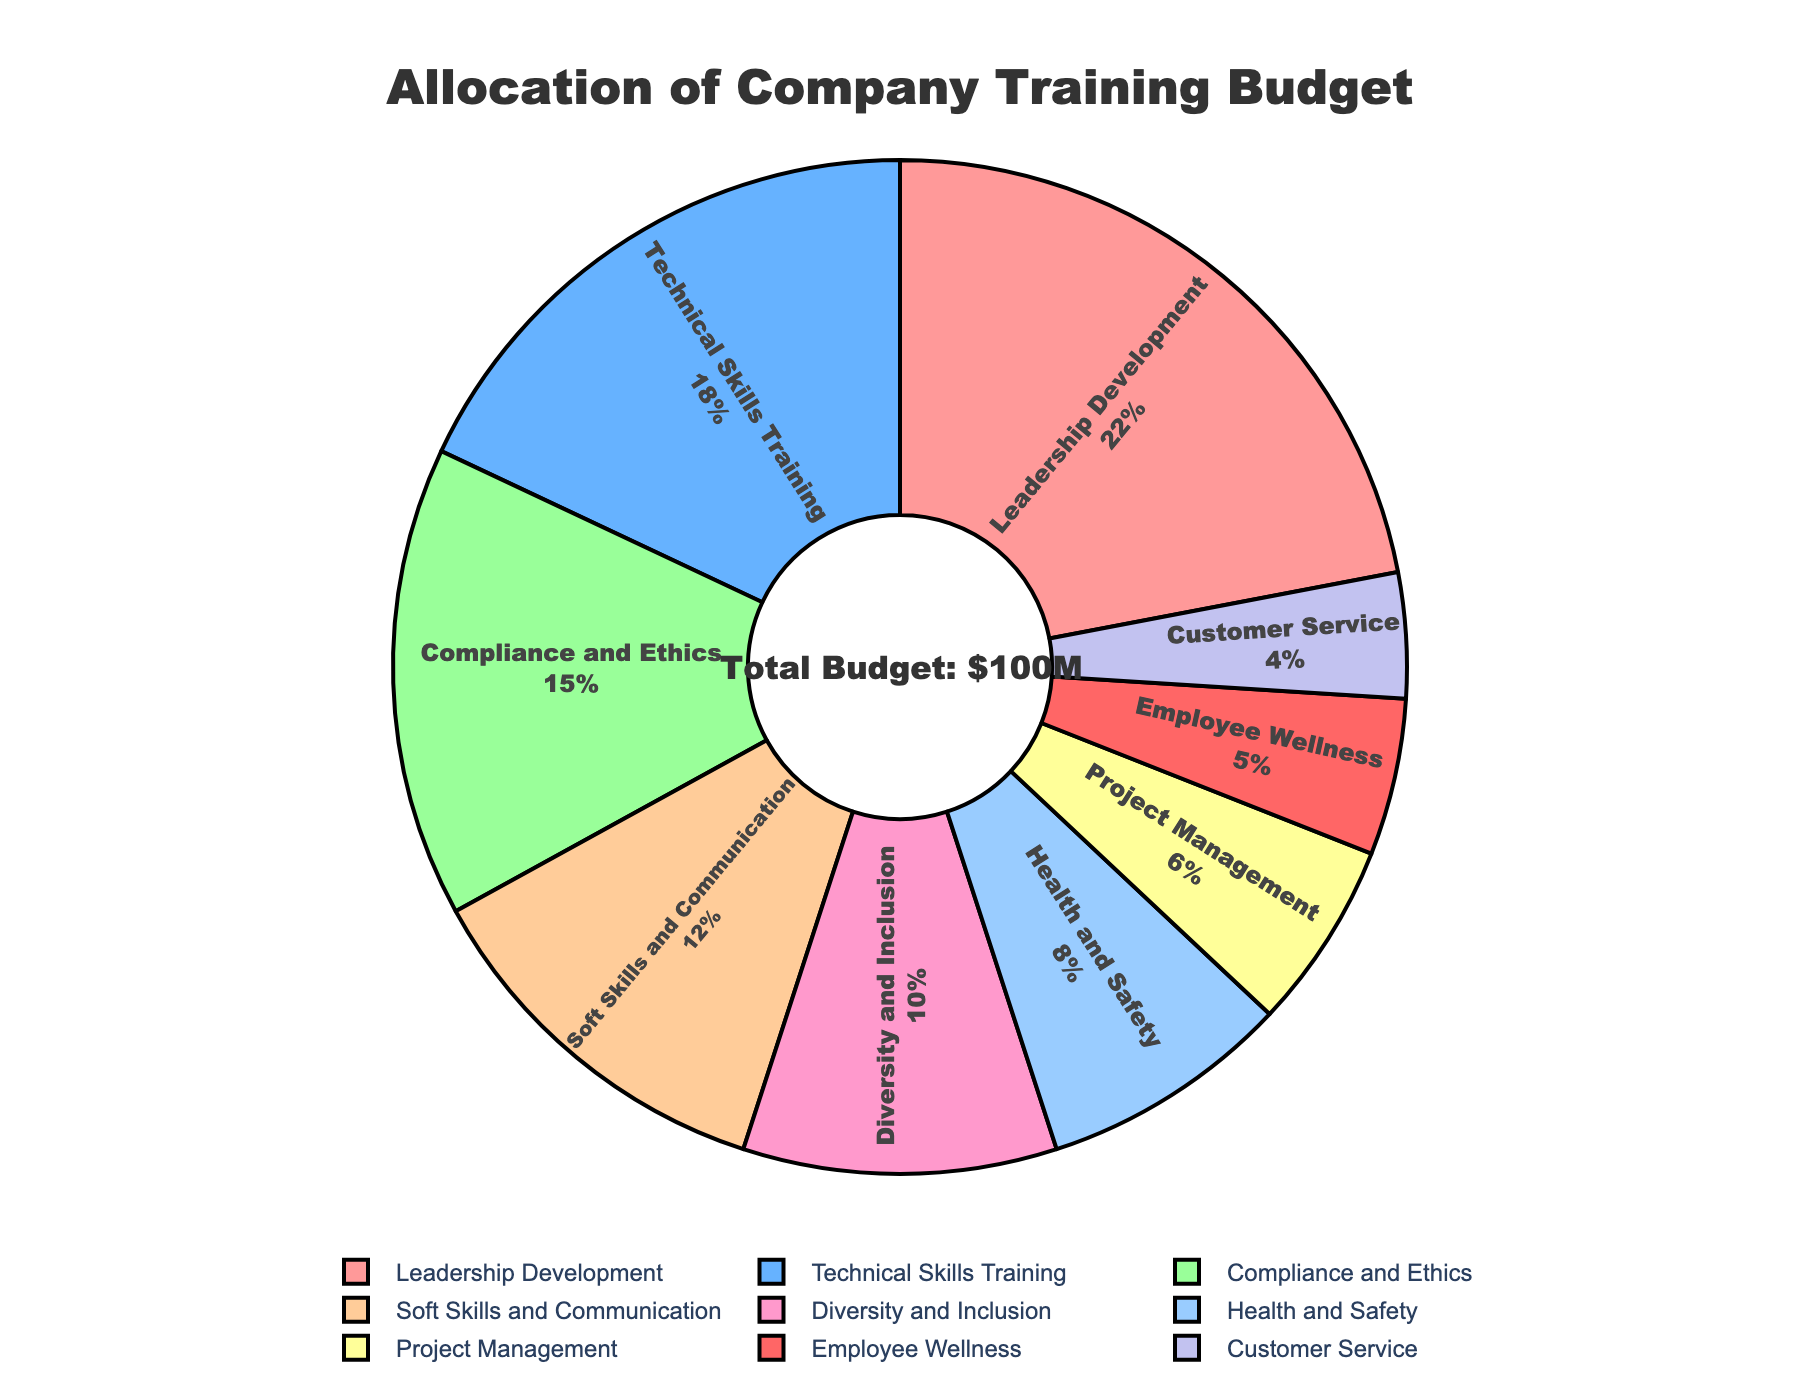What percentage of the budget is allocated to Leadership Development? Identify the slice labeled "Leadership Development" in the pie chart, which shows 22%.
Answer: 22% Which two skill areas receive the smallest portions of the budget? Locate the smallest slices in the pie chart which are labeled "Customer Service" and "Employee Wellness", with 4% and 5% respectively.
Answer: Customer Service and Employee Wellness How much more is spent on Technical Skills Training compared to Customer Service? Find the values for Technical Skills Training (18) and Customer Service (4). Subtract the latter from the former: 18 - 4 = 14M.
Answer: 14M What is the combined budget allocation for Compliance and Ethics, and Health and Safety? Sum the percentages allocated to Compliance and Ethics (15) and Health and Safety (8). The combined allocation is 15 + 8 = 23%.
Answer: 23% What percentage of the budget is allocated to both Diversity and Inclusion and Employee Wellness together? Add the percentages for Diversity and Inclusion (10) and Employee Wellness (5). The total is 10 + 5 = 15%.
Answer: 15% Which skill area has the highest budget allocation, and by how much does it exceed the second-highest allocation? Identify the skill area with the highest budget (Leadership Development at 22%) and the second highest (Technical Skills Training at 18%). The difference is 22 - 18 = 4%.
Answer: Leadership Development, 4% How many skill areas have an allocation of 10% or less? Identify the skill areas with 10% or less, which are Diversity and Inclusion, Health and Safety, Project Management, Employee Wellness, and Customer Service (10, 8, 6, 5, and 4% respectively). Count them, which sums to 5 areas.
Answer: 5 If the total budget is $100 million, what is the dollar amount allocated to Soft Skills and Communication? Multiply the percentage for Soft Skills and Communication (12%) by the total budget. Thus, 0.12 * 100 = $12 million.
Answer: $12 million Is the allocation for Compliance and Ethics greater than the allocation for Project Management and Customer Service combined? Find the allocation for Compliance and Ethics (15%) and compare it to the combined total for Project Management (6%) and Customer Service (4%). Sum them: 6 + 4 = 10%. Since 15% > 10%, the answer is yes.
Answer: Yes What is the visual attribute (color) assigned to the Technical Skills Training slice? Locate the slice labeled "Technical Skills Training" in the pie chart, which is colored blue.
Answer: Blue 